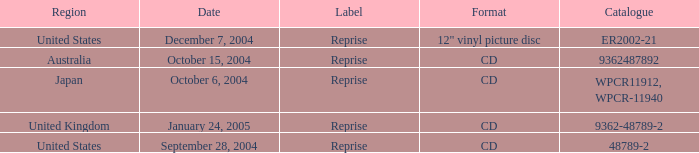Identify the region related to december 7, 2004. United States. 